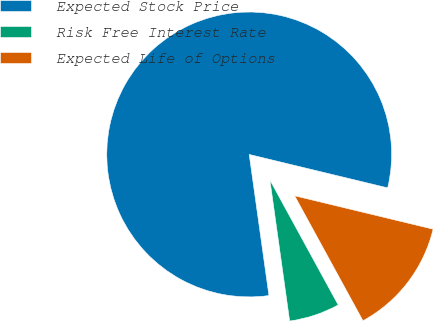<chart> <loc_0><loc_0><loc_500><loc_500><pie_chart><fcel>Expected Stock Price<fcel>Risk Free Interest Rate<fcel>Expected Life of Options<nl><fcel>80.98%<fcel>5.75%<fcel>13.27%<nl></chart> 